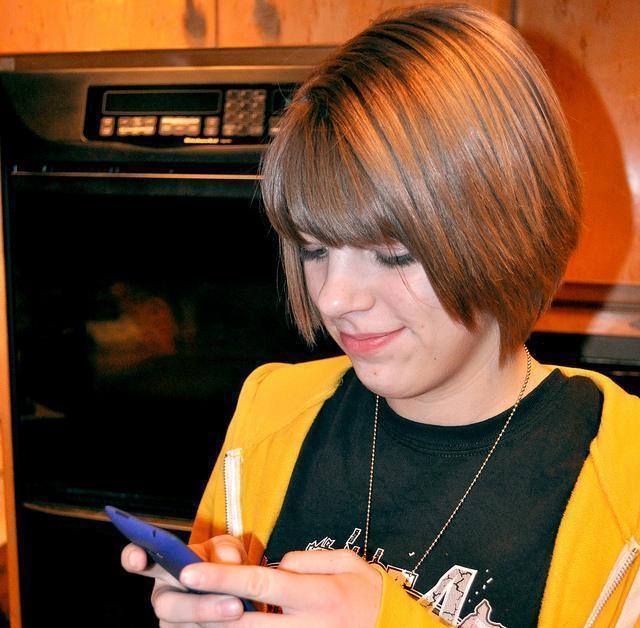What is she doing?
Select the correct answer and articulate reasoning with the following format: 'Answer: answer
Rationale: rationale.'
Options: Playing music, learning phone, using phone, cleaning phone. Answer: using phone.
Rationale: The woman is holding a cell phone and typing. 